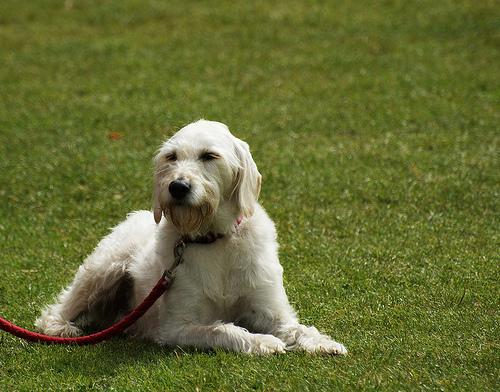Question: what animal is in the picture?
Choices:
A. Dog.
B. Deer.
C. Skunk.
D. Walrus.
Answer with the letter. Answer: A Question: what is the dog sitting on?
Choices:
A. A pillow.
B. Grass.
C. The sofa.
D. The table.
Answer with the letter. Answer: B Question: what color is the grass?
Choices:
A. Yellow.
B. Brown.
C. Blue.
D. Green.
Answer with the letter. Answer: D Question: what color is the dog?
Choices:
A. White.
B. Brown.
C. Black.
D. Grey.
Answer with the letter. Answer: A Question: how bright is the photo?
Choices:
A. Dull.
B. Bright.
C. Not bright.
D. Slightly bright.
Answer with the letter. Answer: B 